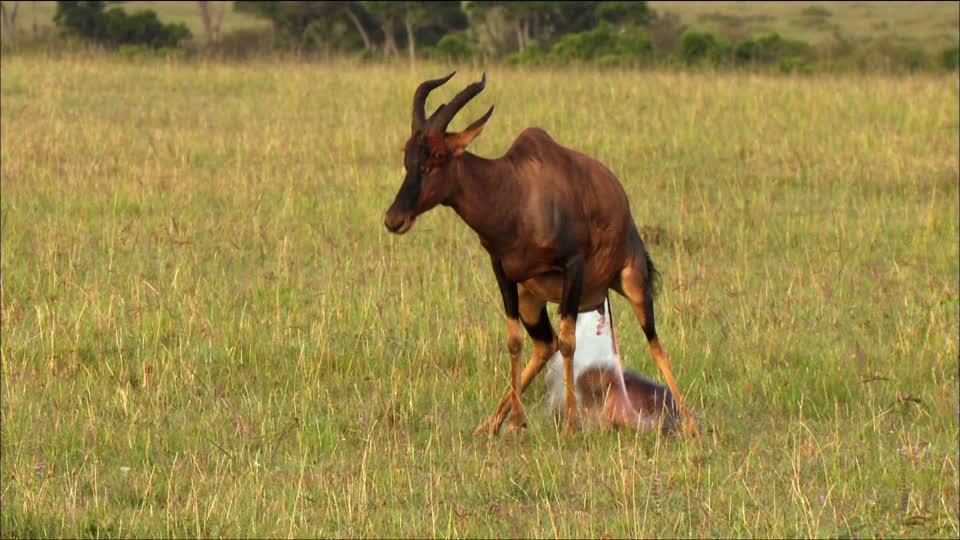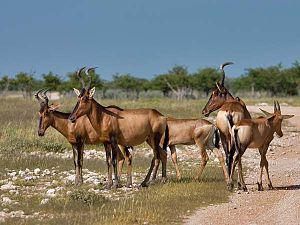The first image is the image on the left, the second image is the image on the right. For the images displayed, is the sentence "An image shows one horned animal with body in profile and face turned toward camera." factually correct? Answer yes or no. No. The first image is the image on the left, the second image is the image on the right. Given the left and right images, does the statement "Each image contains exactly one antelope facing in the same direction." hold true? Answer yes or no. No. 